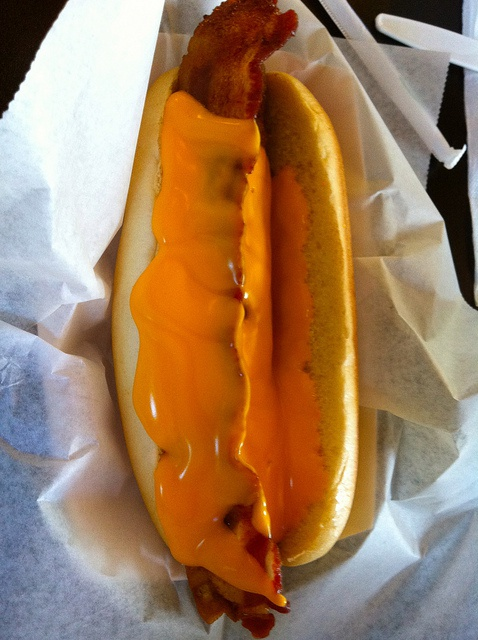Describe the objects in this image and their specific colors. I can see a hot dog in black, brown, red, and maroon tones in this image. 